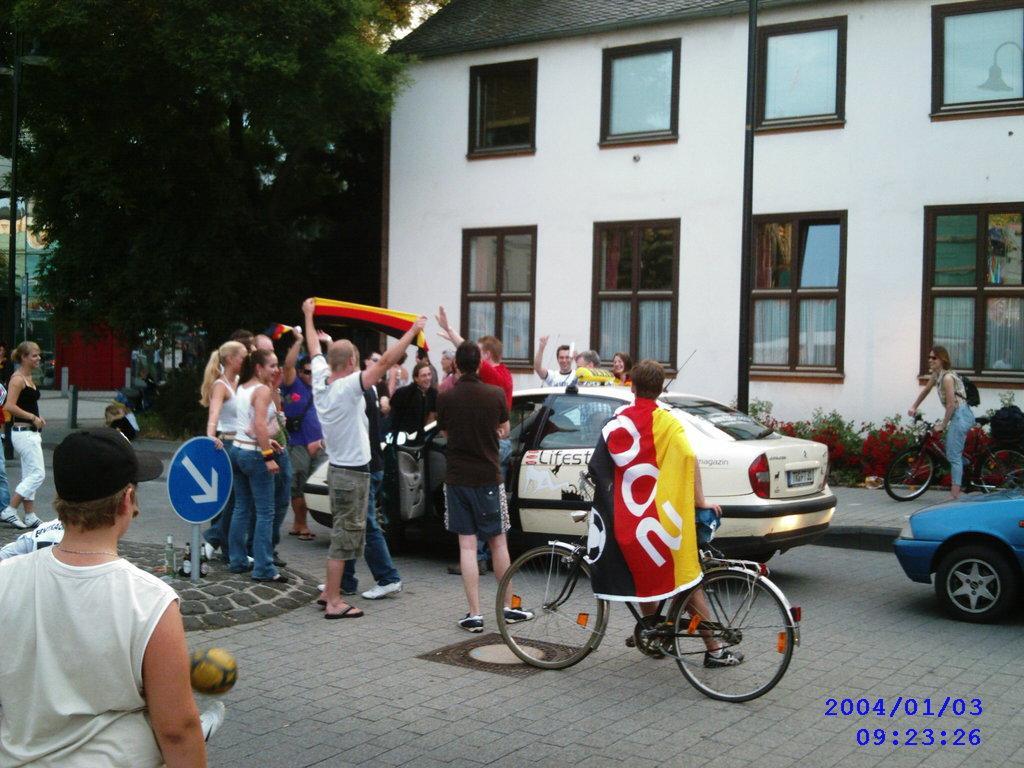In one or two sentences, can you explain what this image depicts? This is the picture of inside of the city. There are group of people standing at the white car and there are two persons holding the bicycle. At the back there is a building and the left there is a tree and in the middle there is a sign board. 